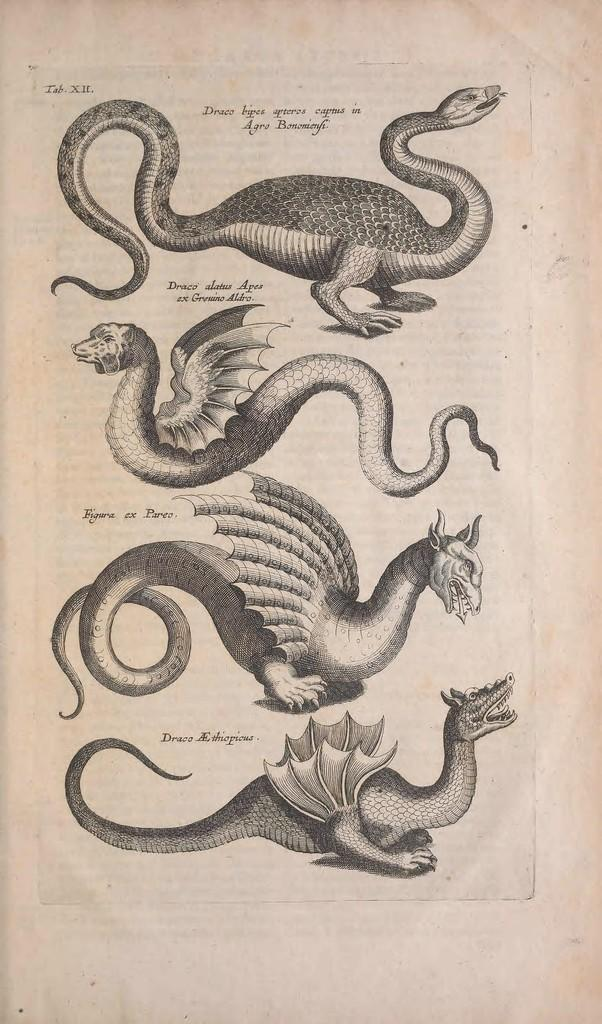What is depicted in the image? There is a drawing in the image. How many animals are included in the drawing? The drawing contains four animals. What else is featured in the drawing besides the animals? There is text present in the drawing. What type of machine is depicted in the drawing? There is no machine present in the drawing; it features four animals and text. Can you tell me how many family members are shown in the drawing? The drawing does not depict any family members; it features four animals and text. 